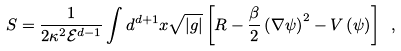<formula> <loc_0><loc_0><loc_500><loc_500>S = \frac { 1 } { 2 \kappa ^ { 2 } { \mathcal { E } } ^ { d - 1 } } \int d ^ { d + 1 } x \sqrt { | g | } \left [ R - \frac { \beta } { 2 } \left ( \nabla \psi \right ) ^ { 2 } - V \left ( \psi \right ) \right ] \ ,</formula> 